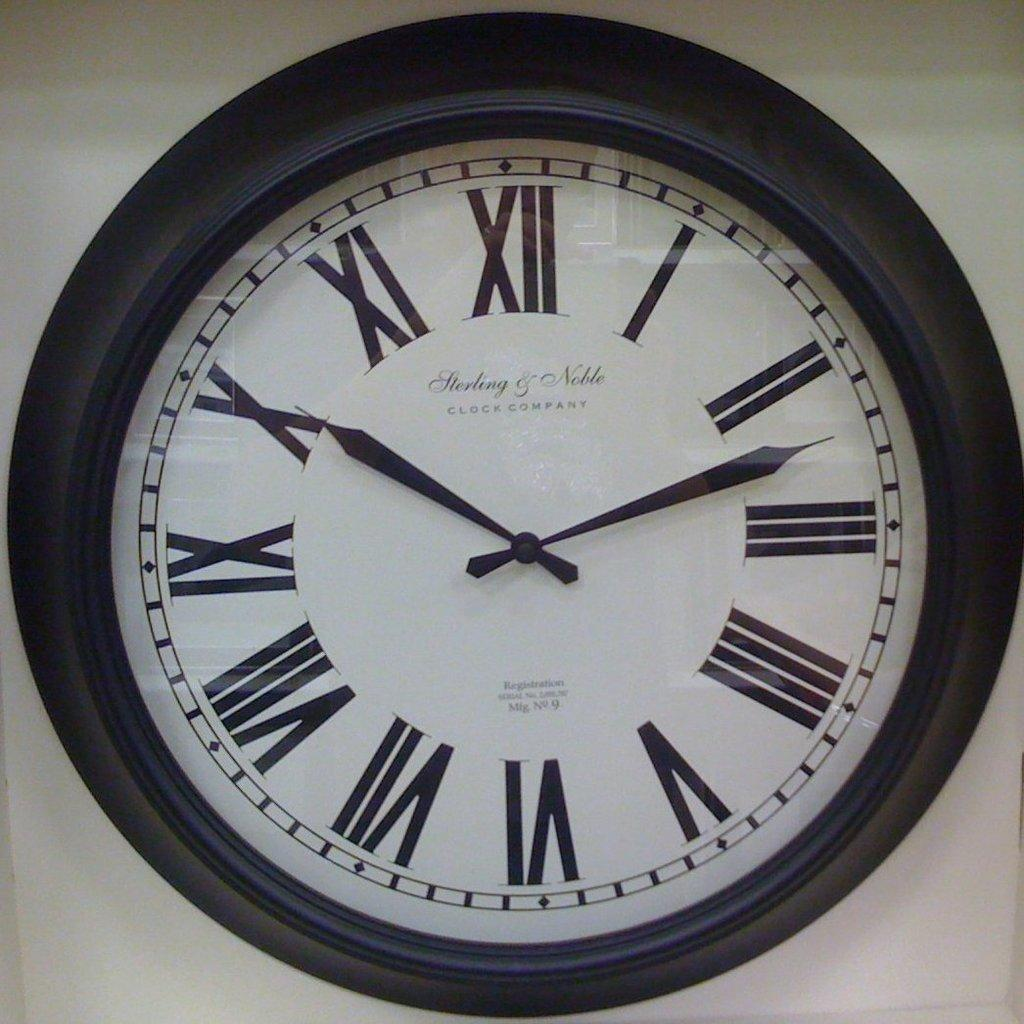<image>
Give a short and clear explanation of the subsequent image. A Sterling and Noble clock hangs against a white wall 